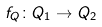<formula> <loc_0><loc_0><loc_500><loc_500>f _ { Q } \colon Q _ { 1 } \rightarrow Q _ { 2 }</formula> 